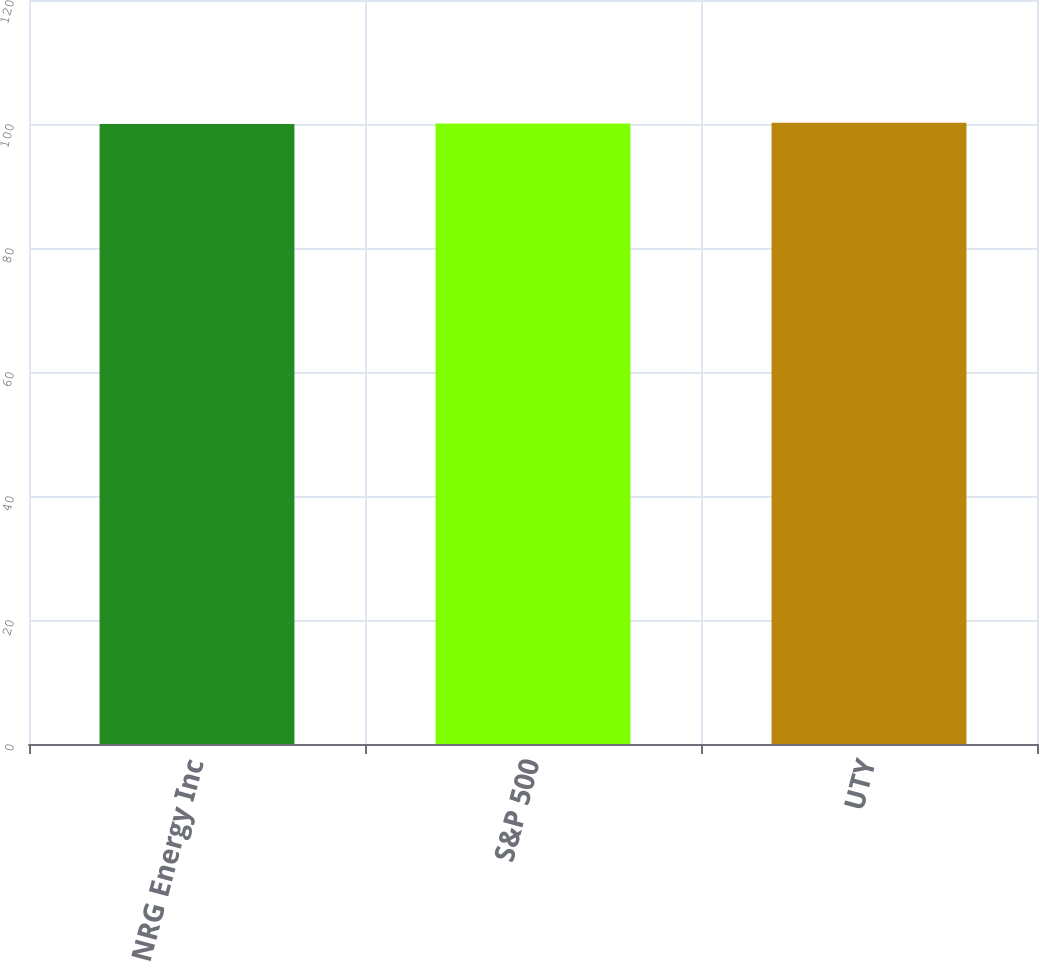Convert chart to OTSL. <chart><loc_0><loc_0><loc_500><loc_500><bar_chart><fcel>NRG Energy Inc<fcel>S&P 500<fcel>UTY<nl><fcel>100<fcel>100.1<fcel>100.2<nl></chart> 